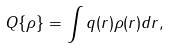<formula> <loc_0><loc_0><loc_500><loc_500>Q \{ \rho \} = \int q ( { r } ) \rho ( { r } ) d { r } ,</formula> 